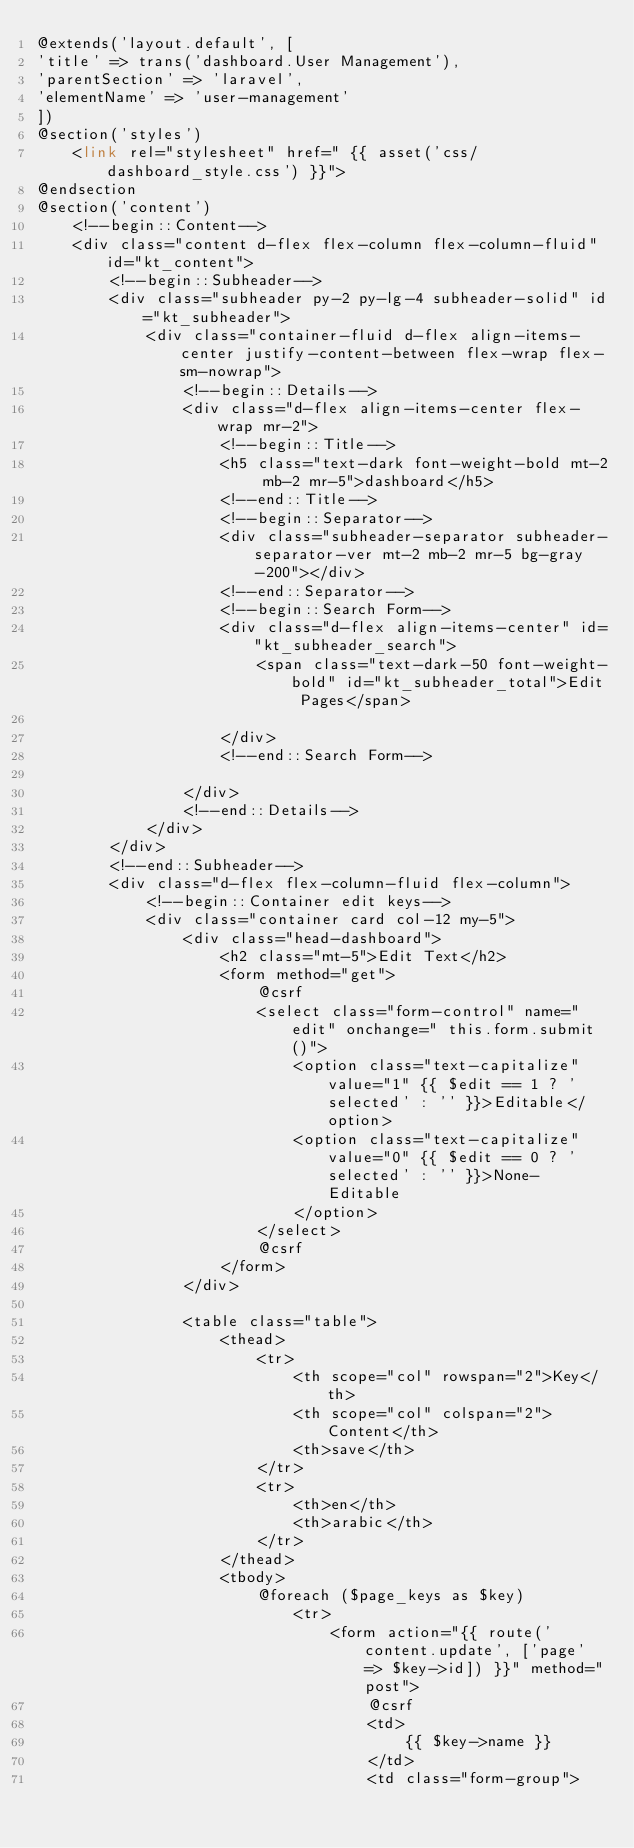Convert code to text. <code><loc_0><loc_0><loc_500><loc_500><_PHP_>@extends('layout.default', [
'title' => trans('dashboard.User Management'),
'parentSection' => 'laravel',
'elementName' => 'user-management'
])
@section('styles')
    <link rel="stylesheet" href=" {{ asset('css/dashboard_style.css') }}">
@endsection
@section('content')
    <!--begin::Content-->
    <div class="content d-flex flex-column flex-column-fluid" id="kt_content">
        <!--begin::Subheader-->
        <div class="subheader py-2 py-lg-4 subheader-solid" id="kt_subheader">
            <div class="container-fluid d-flex align-items-center justify-content-between flex-wrap flex-sm-nowrap">
                <!--begin::Details-->
                <div class="d-flex align-items-center flex-wrap mr-2">
                    <!--begin::Title-->
                    <h5 class="text-dark font-weight-bold mt-2 mb-2 mr-5">dashboard</h5>
                    <!--end::Title-->
                    <!--begin::Separator-->
                    <div class="subheader-separator subheader-separator-ver mt-2 mb-2 mr-5 bg-gray-200"></div>
                    <!--end::Separator-->
                    <!--begin::Search Form-->
                    <div class="d-flex align-items-center" id="kt_subheader_search">
                        <span class="text-dark-50 font-weight-bold" id="kt_subheader_total">Edit Pages</span>

                    </div>
                    <!--end::Search Form-->

                </div>
                <!--end::Details-->
            </div>
        </div>
        <!--end::Subheader-->
        <div class="d-flex flex-column-fluid flex-column">
            <!--begin::Container edit keys-->
            <div class="container card col-12 my-5">
                <div class="head-dashboard">
                    <h2 class="mt-5">Edit Text</h2>
                    <form method="get">
                        @csrf
                        <select class="form-control" name="edit" onchange=" this.form.submit()">
                            <option class="text-capitalize" value="1" {{ $edit == 1 ? 'selected' : '' }}>Editable</option>
                            <option class="text-capitalize" value="0" {{ $edit == 0 ? 'selected' : '' }}>None-Editable
                            </option>
                        </select>
                        @csrf
                    </form>
                </div>

                <table class="table">
                    <thead>
                        <tr>
                            <th scope="col" rowspan="2">Key</th>
                            <th scope="col" colspan="2">Content</th>
                            <th>save</th>
                        </tr>
                        <tr>
                            <th>en</th>
                            <th>arabic</th>
                        </tr>
                    </thead>
                    <tbody>
                        @foreach ($page_keys as $key)
                            <tr>
                                <form action="{{ route('content.update', ['page' => $key->id]) }}" method="post">
                                    @csrf
                                    <td>
                                        {{ $key->name }}
                                    </td>
                                    <td class="form-group"></code> 